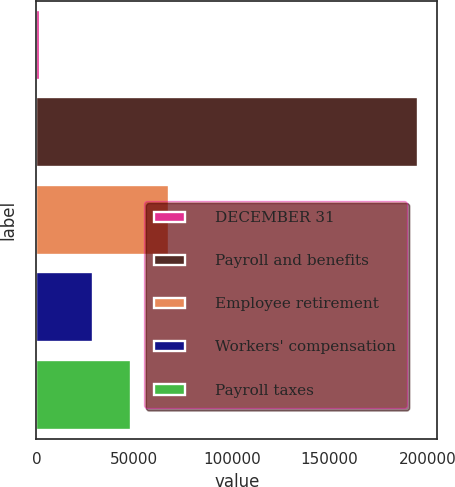Convert chart. <chart><loc_0><loc_0><loc_500><loc_500><bar_chart><fcel>DECEMBER 31<fcel>Payroll and benefits<fcel>Employee retirement<fcel>Workers' compensation<fcel>Payroll taxes<nl><fcel>2007<fcel>195383<fcel>67671.2<fcel>28996<fcel>48333.6<nl></chart> 